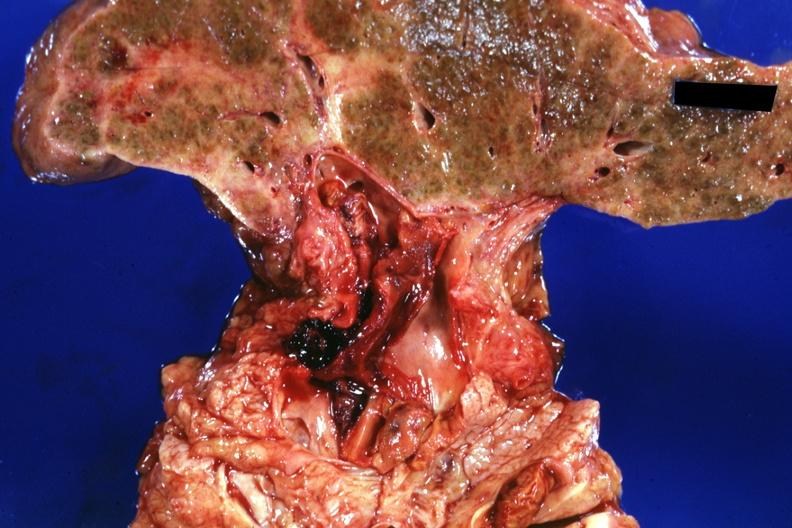s lymphoblastic lymphoma present?
Answer the question using a single word or phrase. No 